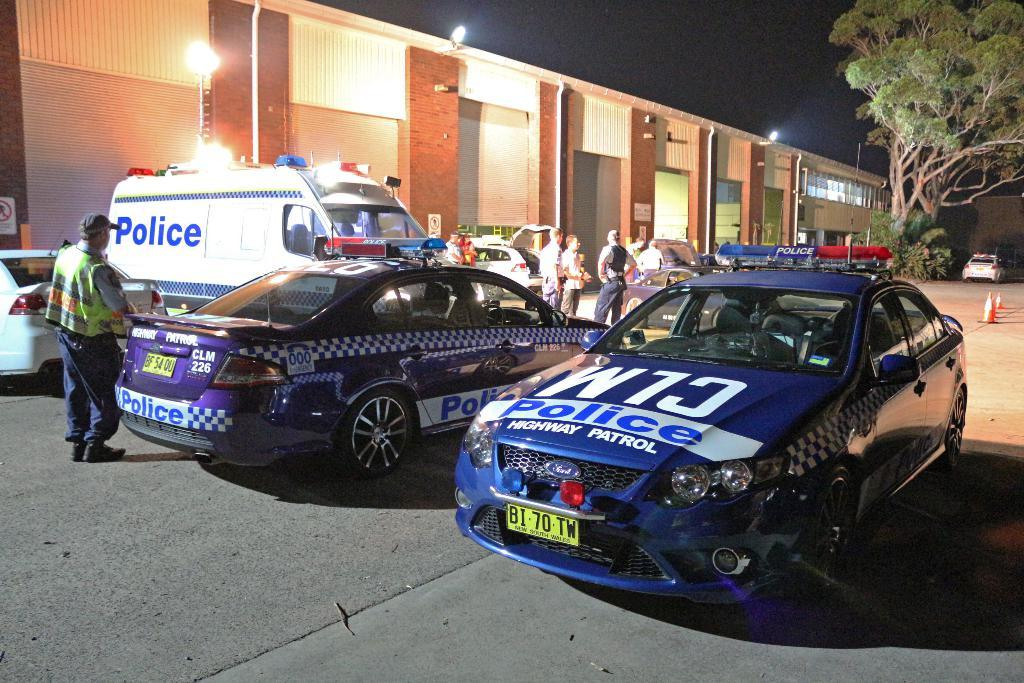What type of structure is visible in the image? There is a house in the image. Are there any additional features near the house? Yes, there are lights near the house. What else can be seen in the image? There are cars, people, and trees in the image. How much coal is being used by the people in the image? There is no mention of coal or its use in the image. --- Facts: 1. There is a person holding a book in the image. 2. The person is sitting on a chair. 3. There is a table in the image. 4. The table has a lamp on it. 5. There is a window in the background. Absurd Topics: parrot, sand, ocean Conversation: What is the person in the image holding? The person is holding a book in the image. What is the person's position in the image? The person is sitting on a chair. What other furniture is visible in the image? There is a table in the image. Are there any additional items on the table? Yes, there is a lamp is on the table. What can be seen in the background of the image? There is a window in the background. Reasoning: Let's think step by step in order to produce the conversation. We start by identifying the main subject in the image, which is the person holding a book. Then, we expand the conversation to include other items that are also visible, such as the chair, table, lamp, and window. Each question is designed to elicit a specific detail about the image that is known from the provided facts. Absurd Question/Answer: Can you see any parrots in the image? There are no parrots present in the image. 